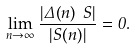<formula> <loc_0><loc_0><loc_500><loc_500>\lim _ { n \rightarrow \infty } \frac { | \Delta ( n ) \ S | } { | S ( n ) | } = 0 .</formula> 